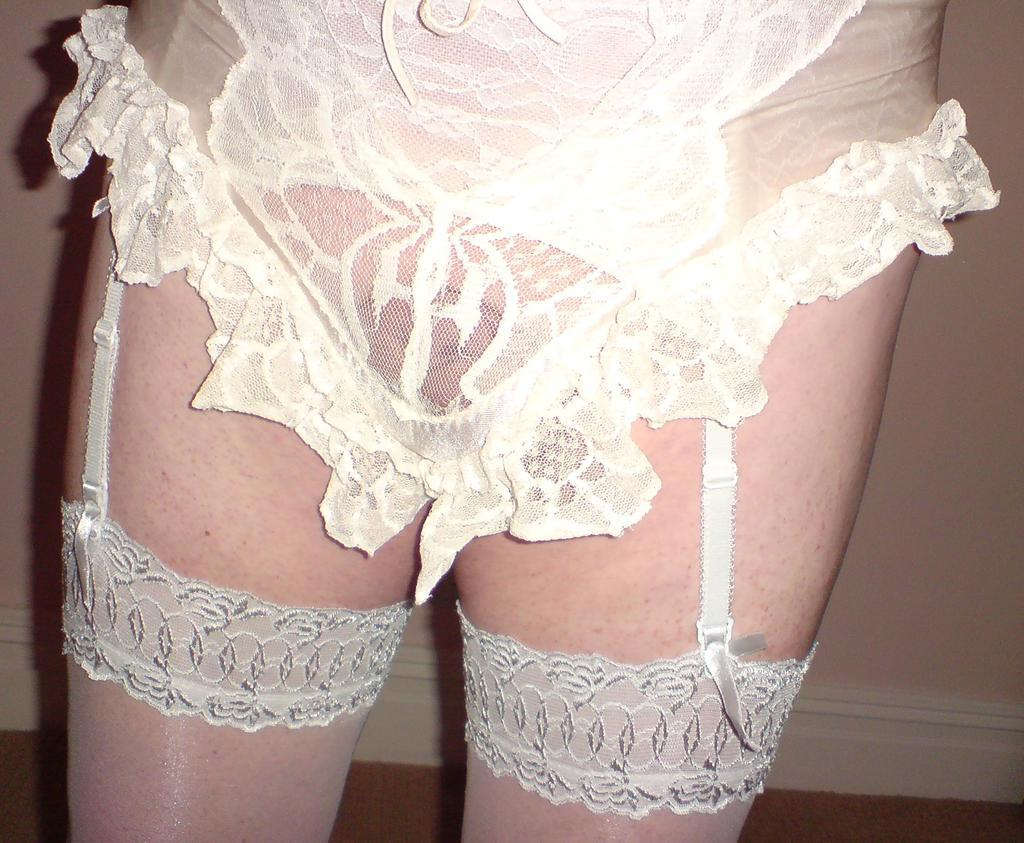What part of a person can be seen in the image? There are legs of a person visible in the image. What is the person wearing in the image? The person is wearing clothes in the image. What type of addition problem can be solved using the numbers on the train in the image? There is no train present in the image, so it is not possible to solve an addition problem using numbers from a train. 